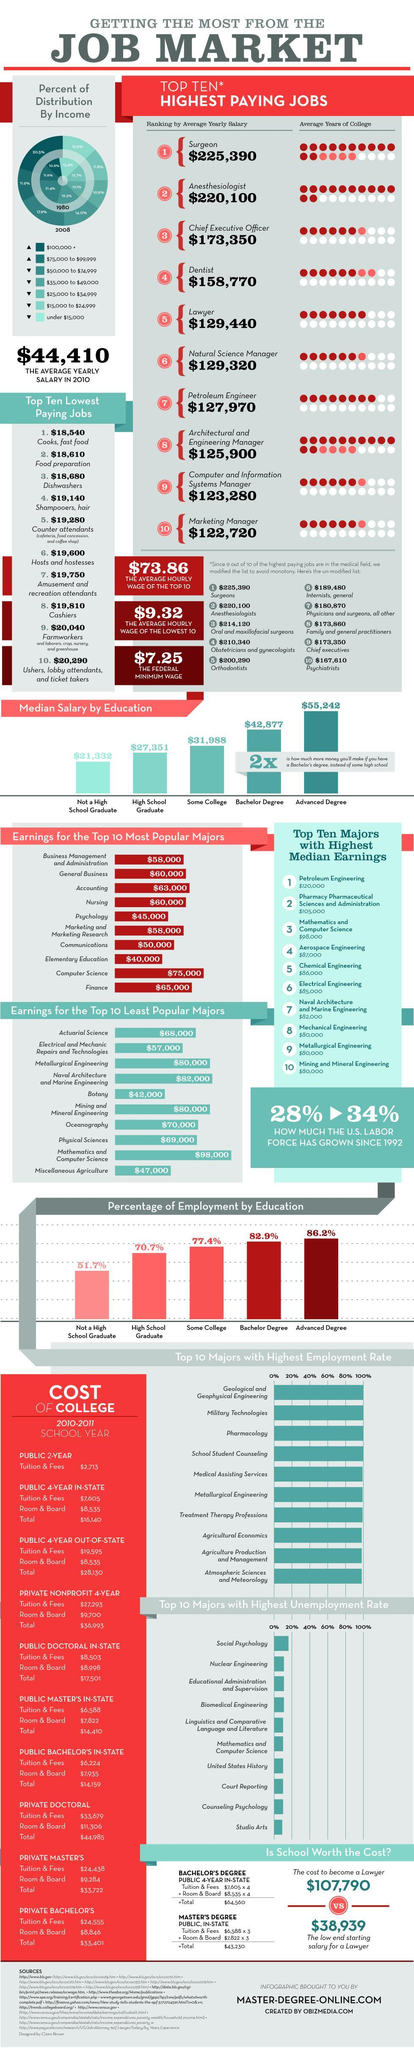What is the percentage growth of the U.S. labor force since 1992?
Answer the question with a short phrase. 34% Which level of education guarantees the highest percentage of employment in the U.S.? Advanced Degree What is the average years of college spend by a lawyer in the U.S.? 7 Which is the second highest paid job in the U.S.? Anesthesiologist What is the ranking given to the Chief Executive Officer based on the average yearly salary? 3 What is the ranking given to a Surgeon based on the average yearly salary? 1 Which is the least paid job in the U.S.? Marketing Manager Which is the highest paid job in the U.S.? Surgeon What is the average yearly salary of a Dentist in the U.S.? $158,770 What is the average yearly salary of a Petroleum Engineer in the U.S.? $127,970 